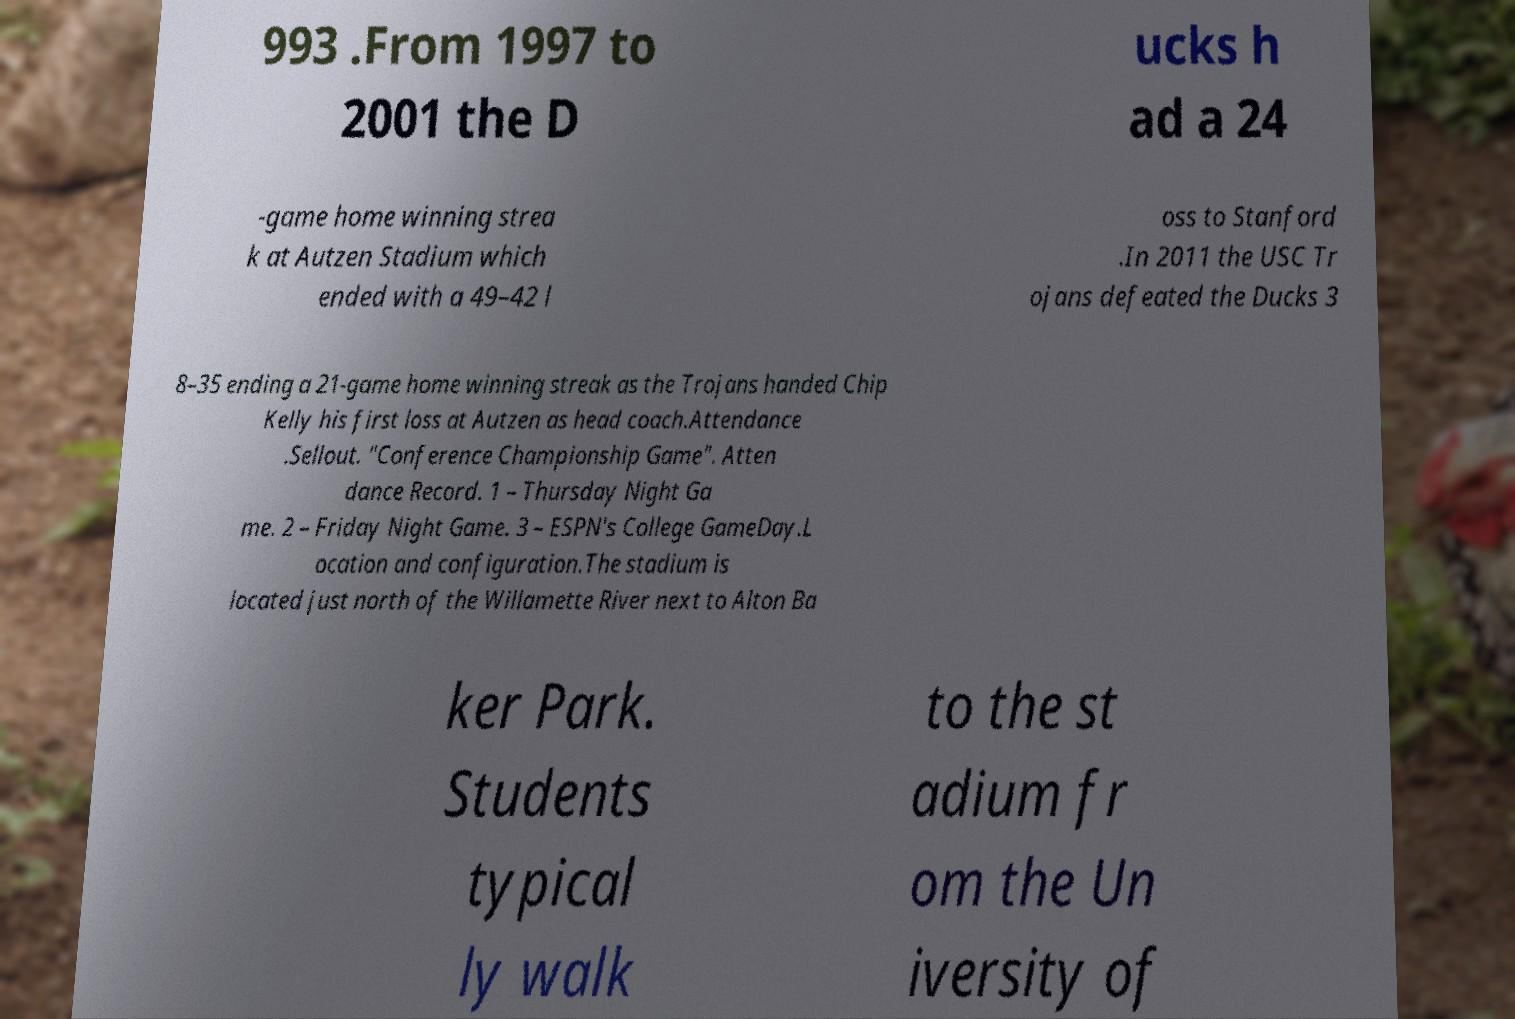Can you accurately transcribe the text from the provided image for me? 993 .From 1997 to 2001 the D ucks h ad a 24 -game home winning strea k at Autzen Stadium which ended with a 49–42 l oss to Stanford .In 2011 the USC Tr ojans defeated the Ducks 3 8–35 ending a 21-game home winning streak as the Trojans handed Chip Kelly his first loss at Autzen as head coach.Attendance .Sellout. "Conference Championship Game". Atten dance Record. 1 – Thursday Night Ga me. 2 – Friday Night Game. 3 – ESPN's College GameDay.L ocation and configuration.The stadium is located just north of the Willamette River next to Alton Ba ker Park. Students typical ly walk to the st adium fr om the Un iversity of 